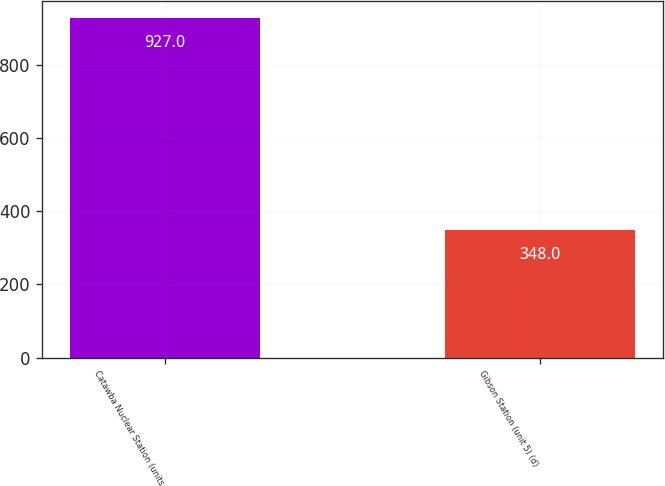Convert chart. <chart><loc_0><loc_0><loc_500><loc_500><bar_chart><fcel>Catawba Nuclear Station (units<fcel>Gibson Station (unit 5) (d)<nl><fcel>927<fcel>348<nl></chart> 